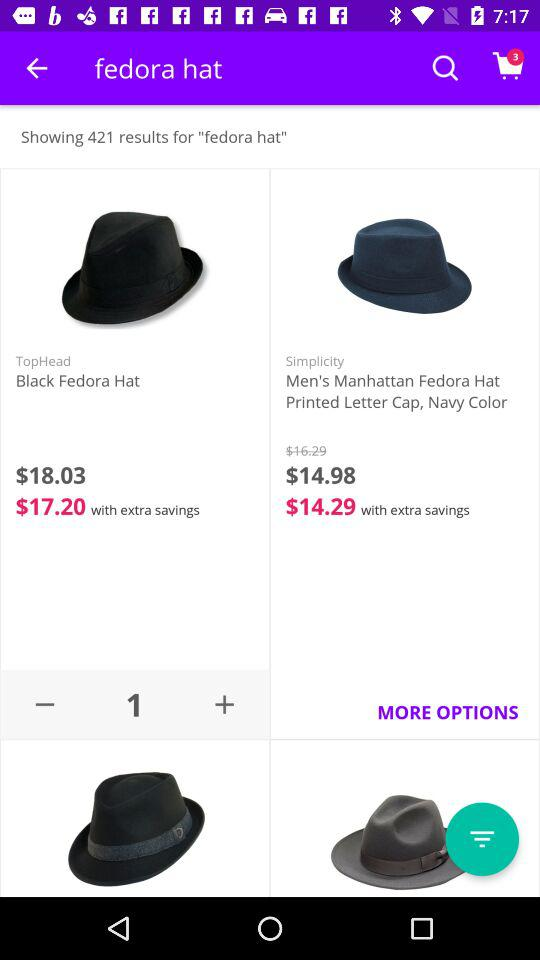What is the color of the "Men's Manhattan Fedora Hat"? The color of the "Men's Manhattan Fedora Hat" is navy. 